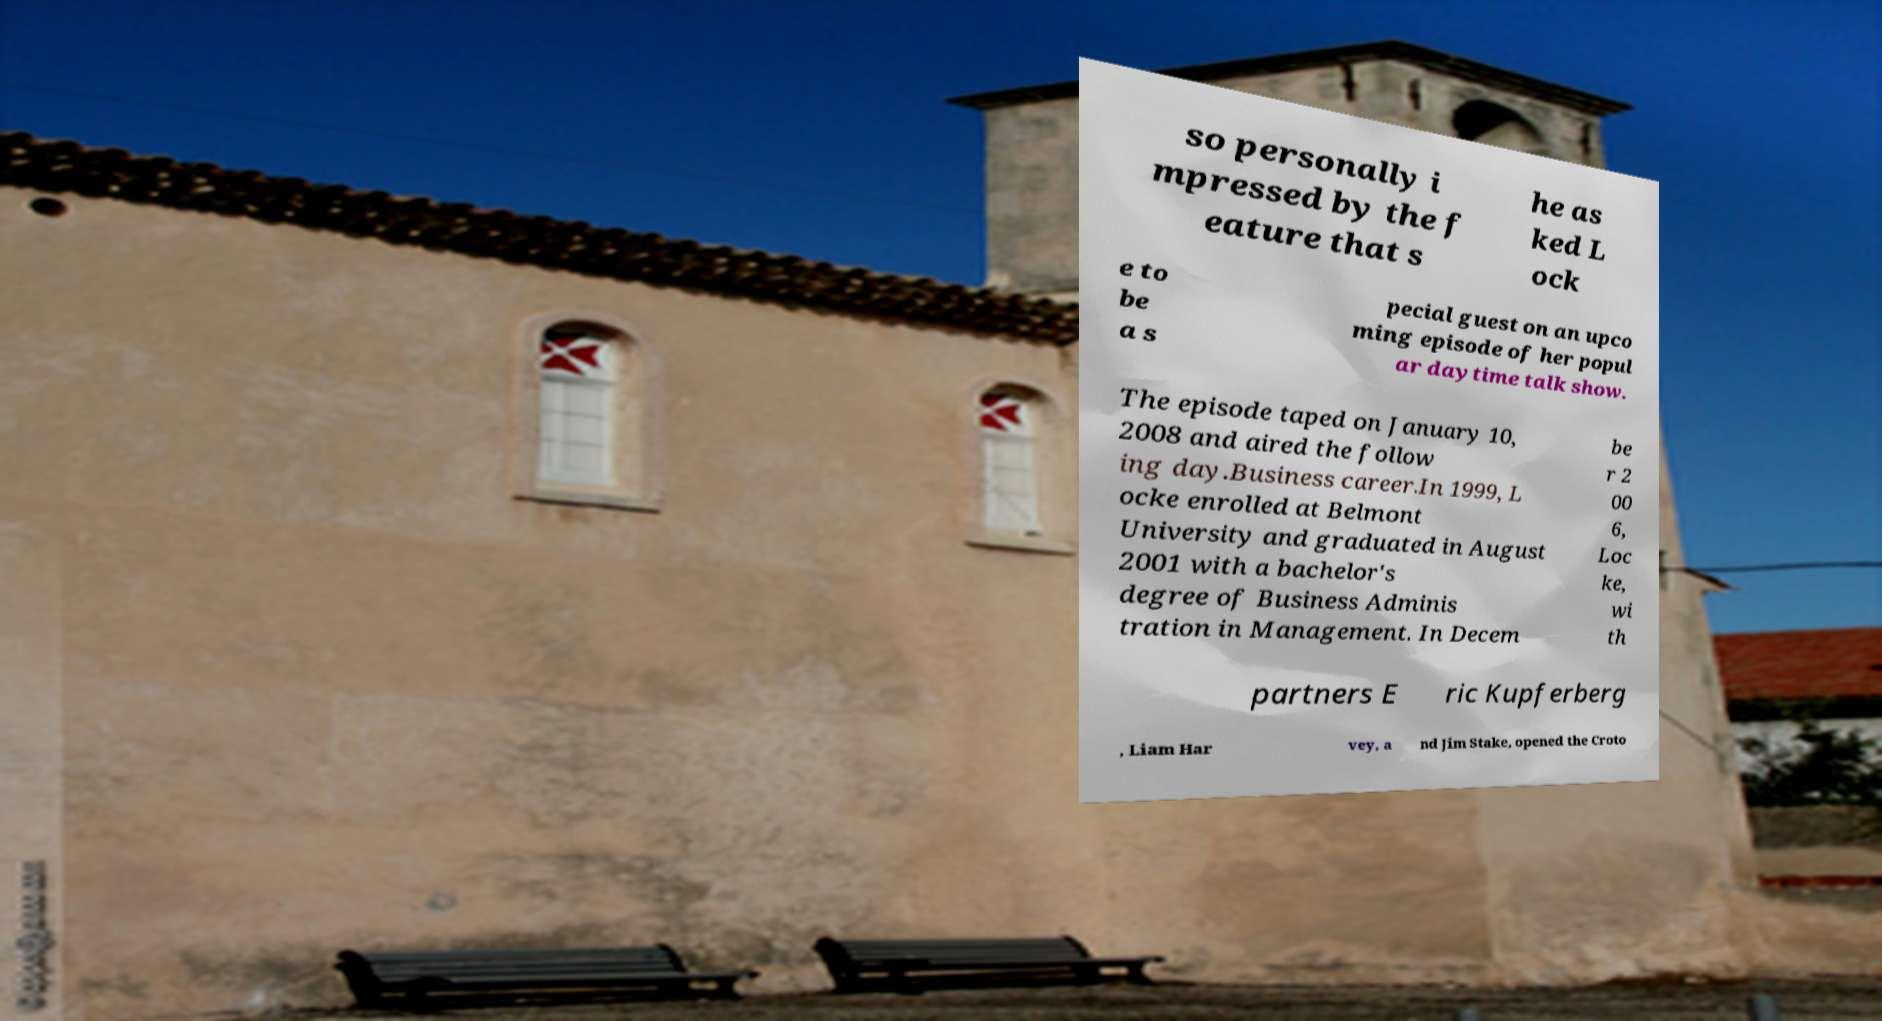Please identify and transcribe the text found in this image. so personally i mpressed by the f eature that s he as ked L ock e to be a s pecial guest on an upco ming episode of her popul ar daytime talk show. The episode taped on January 10, 2008 and aired the follow ing day.Business career.In 1999, L ocke enrolled at Belmont University and graduated in August 2001 with a bachelor's degree of Business Adminis tration in Management. In Decem be r 2 00 6, Loc ke, wi th partners E ric Kupferberg , Liam Har vey, a nd Jim Stake, opened the Croto 